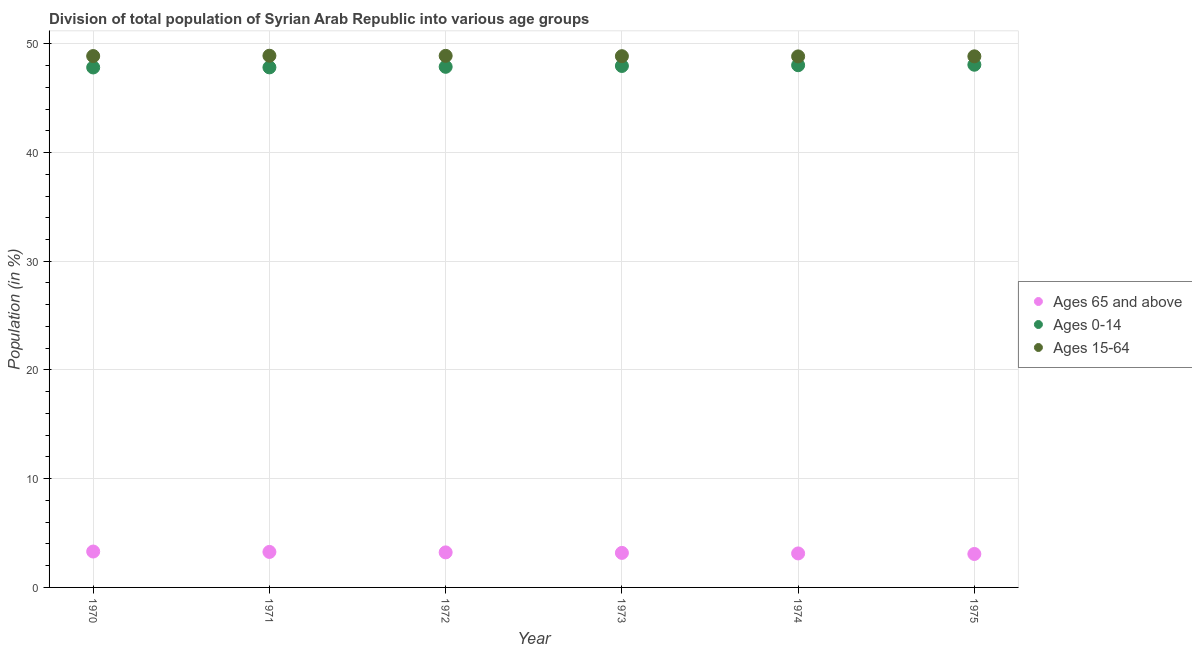How many different coloured dotlines are there?
Provide a short and direct response. 3. Is the number of dotlines equal to the number of legend labels?
Provide a short and direct response. Yes. What is the percentage of population within the age-group 0-14 in 1972?
Keep it short and to the point. 47.88. Across all years, what is the maximum percentage of population within the age-group 0-14?
Offer a terse response. 48.08. Across all years, what is the minimum percentage of population within the age-group 15-64?
Keep it short and to the point. 48.84. In which year was the percentage of population within the age-group of 65 and above minimum?
Make the answer very short. 1975. What is the total percentage of population within the age-group 0-14 in the graph?
Your response must be concise. 287.61. What is the difference between the percentage of population within the age-group of 65 and above in 1971 and that in 1974?
Your response must be concise. 0.14. What is the difference between the percentage of population within the age-group 0-14 in 1973 and the percentage of population within the age-group of 65 and above in 1971?
Your answer should be very brief. 44.7. What is the average percentage of population within the age-group 0-14 per year?
Ensure brevity in your answer.  47.93. In the year 1974, what is the difference between the percentage of population within the age-group 15-64 and percentage of population within the age-group 0-14?
Make the answer very short. 0.81. What is the ratio of the percentage of population within the age-group of 65 and above in 1970 to that in 1971?
Give a very brief answer. 1.01. Is the difference between the percentage of population within the age-group 0-14 in 1971 and 1974 greater than the difference between the percentage of population within the age-group of 65 and above in 1971 and 1974?
Ensure brevity in your answer.  No. What is the difference between the highest and the second highest percentage of population within the age-group of 65 and above?
Your answer should be very brief. 0.04. What is the difference between the highest and the lowest percentage of population within the age-group 0-14?
Provide a short and direct response. 0.25. Is the sum of the percentage of population within the age-group of 65 and above in 1970 and 1973 greater than the maximum percentage of population within the age-group 0-14 across all years?
Your answer should be compact. No. Is it the case that in every year, the sum of the percentage of population within the age-group of 65 and above and percentage of population within the age-group 0-14 is greater than the percentage of population within the age-group 15-64?
Your answer should be very brief. Yes. Is the percentage of population within the age-group 0-14 strictly less than the percentage of population within the age-group 15-64 over the years?
Make the answer very short. Yes. How many dotlines are there?
Offer a terse response. 3. What is the difference between two consecutive major ticks on the Y-axis?
Make the answer very short. 10. Where does the legend appear in the graph?
Your answer should be very brief. Center right. What is the title of the graph?
Offer a very short reply. Division of total population of Syrian Arab Republic into various age groups
. Does "Ireland" appear as one of the legend labels in the graph?
Offer a very short reply. No. What is the label or title of the X-axis?
Give a very brief answer. Year. What is the Population (in %) of Ages 65 and above in 1970?
Your response must be concise. 3.3. What is the Population (in %) of Ages 0-14 in 1970?
Your answer should be compact. 47.83. What is the Population (in %) of Ages 15-64 in 1970?
Provide a succinct answer. 48.87. What is the Population (in %) in Ages 65 and above in 1971?
Keep it short and to the point. 3.27. What is the Population (in %) of Ages 0-14 in 1971?
Your answer should be very brief. 47.83. What is the Population (in %) of Ages 15-64 in 1971?
Ensure brevity in your answer.  48.9. What is the Population (in %) in Ages 65 and above in 1972?
Your response must be concise. 3.22. What is the Population (in %) of Ages 0-14 in 1972?
Give a very brief answer. 47.88. What is the Population (in %) of Ages 15-64 in 1972?
Provide a short and direct response. 48.89. What is the Population (in %) in Ages 65 and above in 1973?
Offer a very short reply. 3.18. What is the Population (in %) in Ages 0-14 in 1973?
Your answer should be compact. 47.96. What is the Population (in %) in Ages 15-64 in 1973?
Keep it short and to the point. 48.86. What is the Population (in %) of Ages 65 and above in 1974?
Your answer should be very brief. 3.13. What is the Population (in %) in Ages 0-14 in 1974?
Ensure brevity in your answer.  48.03. What is the Population (in %) in Ages 15-64 in 1974?
Your answer should be compact. 48.84. What is the Population (in %) in Ages 65 and above in 1975?
Your response must be concise. 3.08. What is the Population (in %) of Ages 0-14 in 1975?
Make the answer very short. 48.08. What is the Population (in %) in Ages 15-64 in 1975?
Offer a terse response. 48.85. Across all years, what is the maximum Population (in %) of Ages 65 and above?
Provide a succinct answer. 3.3. Across all years, what is the maximum Population (in %) in Ages 0-14?
Your answer should be very brief. 48.08. Across all years, what is the maximum Population (in %) of Ages 15-64?
Provide a succinct answer. 48.9. Across all years, what is the minimum Population (in %) of Ages 65 and above?
Make the answer very short. 3.08. Across all years, what is the minimum Population (in %) in Ages 0-14?
Offer a terse response. 47.83. Across all years, what is the minimum Population (in %) of Ages 15-64?
Offer a terse response. 48.84. What is the total Population (in %) of Ages 65 and above in the graph?
Keep it short and to the point. 19.17. What is the total Population (in %) in Ages 0-14 in the graph?
Provide a short and direct response. 287.61. What is the total Population (in %) of Ages 15-64 in the graph?
Your answer should be compact. 293.22. What is the difference between the Population (in %) in Ages 65 and above in 1970 and that in 1971?
Provide a short and direct response. 0.04. What is the difference between the Population (in %) in Ages 0-14 in 1970 and that in 1971?
Your answer should be compact. -0.01. What is the difference between the Population (in %) of Ages 15-64 in 1970 and that in 1971?
Give a very brief answer. -0.03. What is the difference between the Population (in %) of Ages 65 and above in 1970 and that in 1972?
Your response must be concise. 0.08. What is the difference between the Population (in %) in Ages 0-14 in 1970 and that in 1972?
Ensure brevity in your answer.  -0.06. What is the difference between the Population (in %) of Ages 15-64 in 1970 and that in 1972?
Your answer should be compact. -0.02. What is the difference between the Population (in %) of Ages 65 and above in 1970 and that in 1973?
Keep it short and to the point. 0.13. What is the difference between the Population (in %) in Ages 0-14 in 1970 and that in 1973?
Provide a succinct answer. -0.14. What is the difference between the Population (in %) of Ages 15-64 in 1970 and that in 1973?
Provide a succinct answer. 0.01. What is the difference between the Population (in %) in Ages 65 and above in 1970 and that in 1974?
Offer a terse response. 0.17. What is the difference between the Population (in %) in Ages 0-14 in 1970 and that in 1974?
Give a very brief answer. -0.21. What is the difference between the Population (in %) in Ages 15-64 in 1970 and that in 1974?
Keep it short and to the point. 0.03. What is the difference between the Population (in %) of Ages 65 and above in 1970 and that in 1975?
Provide a short and direct response. 0.22. What is the difference between the Population (in %) in Ages 0-14 in 1970 and that in 1975?
Your answer should be compact. -0.25. What is the difference between the Population (in %) in Ages 15-64 in 1970 and that in 1975?
Your answer should be compact. 0.03. What is the difference between the Population (in %) of Ages 65 and above in 1971 and that in 1972?
Offer a very short reply. 0.04. What is the difference between the Population (in %) of Ages 0-14 in 1971 and that in 1972?
Ensure brevity in your answer.  -0.05. What is the difference between the Population (in %) of Ages 15-64 in 1971 and that in 1972?
Keep it short and to the point. 0.01. What is the difference between the Population (in %) in Ages 65 and above in 1971 and that in 1973?
Ensure brevity in your answer.  0.09. What is the difference between the Population (in %) of Ages 0-14 in 1971 and that in 1973?
Your answer should be compact. -0.13. What is the difference between the Population (in %) in Ages 15-64 in 1971 and that in 1973?
Keep it short and to the point. 0.04. What is the difference between the Population (in %) of Ages 65 and above in 1971 and that in 1974?
Keep it short and to the point. 0.14. What is the difference between the Population (in %) of Ages 0-14 in 1971 and that in 1974?
Keep it short and to the point. -0.2. What is the difference between the Population (in %) in Ages 15-64 in 1971 and that in 1974?
Offer a very short reply. 0.06. What is the difference between the Population (in %) of Ages 65 and above in 1971 and that in 1975?
Provide a short and direct response. 0.19. What is the difference between the Population (in %) of Ages 0-14 in 1971 and that in 1975?
Offer a very short reply. -0.24. What is the difference between the Population (in %) of Ages 15-64 in 1971 and that in 1975?
Keep it short and to the point. 0.06. What is the difference between the Population (in %) of Ages 65 and above in 1972 and that in 1973?
Your response must be concise. 0.05. What is the difference between the Population (in %) in Ages 0-14 in 1972 and that in 1973?
Ensure brevity in your answer.  -0.08. What is the difference between the Population (in %) in Ages 15-64 in 1972 and that in 1973?
Ensure brevity in your answer.  0.03. What is the difference between the Population (in %) in Ages 65 and above in 1972 and that in 1974?
Your response must be concise. 0.1. What is the difference between the Population (in %) of Ages 0-14 in 1972 and that in 1974?
Provide a succinct answer. -0.15. What is the difference between the Population (in %) of Ages 15-64 in 1972 and that in 1974?
Your answer should be very brief. 0.05. What is the difference between the Population (in %) of Ages 65 and above in 1972 and that in 1975?
Your response must be concise. 0.15. What is the difference between the Population (in %) of Ages 0-14 in 1972 and that in 1975?
Provide a succinct answer. -0.19. What is the difference between the Population (in %) of Ages 15-64 in 1972 and that in 1975?
Provide a succinct answer. 0.05. What is the difference between the Population (in %) in Ages 65 and above in 1973 and that in 1974?
Keep it short and to the point. 0.05. What is the difference between the Population (in %) of Ages 0-14 in 1973 and that in 1974?
Your response must be concise. -0.07. What is the difference between the Population (in %) in Ages 65 and above in 1973 and that in 1975?
Offer a very short reply. 0.1. What is the difference between the Population (in %) of Ages 0-14 in 1973 and that in 1975?
Keep it short and to the point. -0.11. What is the difference between the Population (in %) in Ages 15-64 in 1973 and that in 1975?
Offer a very short reply. 0.01. What is the difference between the Population (in %) of Ages 65 and above in 1974 and that in 1975?
Your response must be concise. 0.05. What is the difference between the Population (in %) of Ages 0-14 in 1974 and that in 1975?
Keep it short and to the point. -0.04. What is the difference between the Population (in %) in Ages 15-64 in 1974 and that in 1975?
Offer a terse response. -0.01. What is the difference between the Population (in %) in Ages 65 and above in 1970 and the Population (in %) in Ages 0-14 in 1971?
Keep it short and to the point. -44.53. What is the difference between the Population (in %) in Ages 65 and above in 1970 and the Population (in %) in Ages 15-64 in 1971?
Make the answer very short. -45.6. What is the difference between the Population (in %) of Ages 0-14 in 1970 and the Population (in %) of Ages 15-64 in 1971?
Your answer should be very brief. -1.08. What is the difference between the Population (in %) in Ages 65 and above in 1970 and the Population (in %) in Ages 0-14 in 1972?
Your answer should be compact. -44.58. What is the difference between the Population (in %) of Ages 65 and above in 1970 and the Population (in %) of Ages 15-64 in 1972?
Give a very brief answer. -45.59. What is the difference between the Population (in %) in Ages 0-14 in 1970 and the Population (in %) in Ages 15-64 in 1972?
Give a very brief answer. -1.07. What is the difference between the Population (in %) of Ages 65 and above in 1970 and the Population (in %) of Ages 0-14 in 1973?
Give a very brief answer. -44.66. What is the difference between the Population (in %) in Ages 65 and above in 1970 and the Population (in %) in Ages 15-64 in 1973?
Provide a succinct answer. -45.56. What is the difference between the Population (in %) of Ages 0-14 in 1970 and the Population (in %) of Ages 15-64 in 1973?
Your answer should be very brief. -1.04. What is the difference between the Population (in %) of Ages 65 and above in 1970 and the Population (in %) of Ages 0-14 in 1974?
Give a very brief answer. -44.73. What is the difference between the Population (in %) in Ages 65 and above in 1970 and the Population (in %) in Ages 15-64 in 1974?
Provide a short and direct response. -45.54. What is the difference between the Population (in %) in Ages 0-14 in 1970 and the Population (in %) in Ages 15-64 in 1974?
Provide a short and direct response. -1.02. What is the difference between the Population (in %) in Ages 65 and above in 1970 and the Population (in %) in Ages 0-14 in 1975?
Keep it short and to the point. -44.77. What is the difference between the Population (in %) in Ages 65 and above in 1970 and the Population (in %) in Ages 15-64 in 1975?
Keep it short and to the point. -45.55. What is the difference between the Population (in %) in Ages 0-14 in 1970 and the Population (in %) in Ages 15-64 in 1975?
Give a very brief answer. -1.02. What is the difference between the Population (in %) in Ages 65 and above in 1971 and the Population (in %) in Ages 0-14 in 1972?
Your answer should be very brief. -44.62. What is the difference between the Population (in %) of Ages 65 and above in 1971 and the Population (in %) of Ages 15-64 in 1972?
Ensure brevity in your answer.  -45.63. What is the difference between the Population (in %) of Ages 0-14 in 1971 and the Population (in %) of Ages 15-64 in 1972?
Provide a short and direct response. -1.06. What is the difference between the Population (in %) in Ages 65 and above in 1971 and the Population (in %) in Ages 0-14 in 1973?
Ensure brevity in your answer.  -44.7. What is the difference between the Population (in %) of Ages 65 and above in 1971 and the Population (in %) of Ages 15-64 in 1973?
Provide a short and direct response. -45.6. What is the difference between the Population (in %) of Ages 0-14 in 1971 and the Population (in %) of Ages 15-64 in 1973?
Keep it short and to the point. -1.03. What is the difference between the Population (in %) in Ages 65 and above in 1971 and the Population (in %) in Ages 0-14 in 1974?
Give a very brief answer. -44.77. What is the difference between the Population (in %) of Ages 65 and above in 1971 and the Population (in %) of Ages 15-64 in 1974?
Keep it short and to the point. -45.58. What is the difference between the Population (in %) of Ages 0-14 in 1971 and the Population (in %) of Ages 15-64 in 1974?
Make the answer very short. -1.01. What is the difference between the Population (in %) in Ages 65 and above in 1971 and the Population (in %) in Ages 0-14 in 1975?
Give a very brief answer. -44.81. What is the difference between the Population (in %) of Ages 65 and above in 1971 and the Population (in %) of Ages 15-64 in 1975?
Your answer should be very brief. -45.58. What is the difference between the Population (in %) in Ages 0-14 in 1971 and the Population (in %) in Ages 15-64 in 1975?
Your response must be concise. -1.02. What is the difference between the Population (in %) in Ages 65 and above in 1972 and the Population (in %) in Ages 0-14 in 1973?
Your response must be concise. -44.74. What is the difference between the Population (in %) in Ages 65 and above in 1972 and the Population (in %) in Ages 15-64 in 1973?
Make the answer very short. -45.64. What is the difference between the Population (in %) of Ages 0-14 in 1972 and the Population (in %) of Ages 15-64 in 1973?
Your answer should be compact. -0.98. What is the difference between the Population (in %) in Ages 65 and above in 1972 and the Population (in %) in Ages 0-14 in 1974?
Provide a succinct answer. -44.81. What is the difference between the Population (in %) in Ages 65 and above in 1972 and the Population (in %) in Ages 15-64 in 1974?
Provide a succinct answer. -45.62. What is the difference between the Population (in %) of Ages 0-14 in 1972 and the Population (in %) of Ages 15-64 in 1974?
Offer a very short reply. -0.96. What is the difference between the Population (in %) in Ages 65 and above in 1972 and the Population (in %) in Ages 0-14 in 1975?
Ensure brevity in your answer.  -44.85. What is the difference between the Population (in %) in Ages 65 and above in 1972 and the Population (in %) in Ages 15-64 in 1975?
Keep it short and to the point. -45.62. What is the difference between the Population (in %) in Ages 0-14 in 1972 and the Population (in %) in Ages 15-64 in 1975?
Offer a very short reply. -0.96. What is the difference between the Population (in %) of Ages 65 and above in 1973 and the Population (in %) of Ages 0-14 in 1974?
Provide a short and direct response. -44.85. What is the difference between the Population (in %) in Ages 65 and above in 1973 and the Population (in %) in Ages 15-64 in 1974?
Offer a very short reply. -45.67. What is the difference between the Population (in %) of Ages 0-14 in 1973 and the Population (in %) of Ages 15-64 in 1974?
Make the answer very short. -0.88. What is the difference between the Population (in %) in Ages 65 and above in 1973 and the Population (in %) in Ages 0-14 in 1975?
Provide a succinct answer. -44.9. What is the difference between the Population (in %) in Ages 65 and above in 1973 and the Population (in %) in Ages 15-64 in 1975?
Make the answer very short. -45.67. What is the difference between the Population (in %) of Ages 0-14 in 1973 and the Population (in %) of Ages 15-64 in 1975?
Ensure brevity in your answer.  -0.89. What is the difference between the Population (in %) of Ages 65 and above in 1974 and the Population (in %) of Ages 0-14 in 1975?
Keep it short and to the point. -44.95. What is the difference between the Population (in %) in Ages 65 and above in 1974 and the Population (in %) in Ages 15-64 in 1975?
Offer a terse response. -45.72. What is the difference between the Population (in %) in Ages 0-14 in 1974 and the Population (in %) in Ages 15-64 in 1975?
Ensure brevity in your answer.  -0.82. What is the average Population (in %) of Ages 65 and above per year?
Make the answer very short. 3.2. What is the average Population (in %) in Ages 0-14 per year?
Your answer should be compact. 47.93. What is the average Population (in %) in Ages 15-64 per year?
Make the answer very short. 48.87. In the year 1970, what is the difference between the Population (in %) of Ages 65 and above and Population (in %) of Ages 0-14?
Give a very brief answer. -44.52. In the year 1970, what is the difference between the Population (in %) in Ages 65 and above and Population (in %) in Ages 15-64?
Provide a succinct answer. -45.57. In the year 1970, what is the difference between the Population (in %) of Ages 0-14 and Population (in %) of Ages 15-64?
Your response must be concise. -1.05. In the year 1971, what is the difference between the Population (in %) of Ages 65 and above and Population (in %) of Ages 0-14?
Make the answer very short. -44.57. In the year 1971, what is the difference between the Population (in %) in Ages 65 and above and Population (in %) in Ages 15-64?
Give a very brief answer. -45.64. In the year 1971, what is the difference between the Population (in %) in Ages 0-14 and Population (in %) in Ages 15-64?
Offer a terse response. -1.07. In the year 1972, what is the difference between the Population (in %) in Ages 65 and above and Population (in %) in Ages 0-14?
Give a very brief answer. -44.66. In the year 1972, what is the difference between the Population (in %) in Ages 65 and above and Population (in %) in Ages 15-64?
Your response must be concise. -45.67. In the year 1972, what is the difference between the Population (in %) of Ages 0-14 and Population (in %) of Ages 15-64?
Your answer should be compact. -1.01. In the year 1973, what is the difference between the Population (in %) of Ages 65 and above and Population (in %) of Ages 0-14?
Provide a short and direct response. -44.79. In the year 1973, what is the difference between the Population (in %) in Ages 65 and above and Population (in %) in Ages 15-64?
Provide a succinct answer. -45.69. In the year 1973, what is the difference between the Population (in %) of Ages 0-14 and Population (in %) of Ages 15-64?
Your answer should be very brief. -0.9. In the year 1974, what is the difference between the Population (in %) of Ages 65 and above and Population (in %) of Ages 0-14?
Provide a succinct answer. -44.9. In the year 1974, what is the difference between the Population (in %) of Ages 65 and above and Population (in %) of Ages 15-64?
Give a very brief answer. -45.71. In the year 1974, what is the difference between the Population (in %) in Ages 0-14 and Population (in %) in Ages 15-64?
Keep it short and to the point. -0.81. In the year 1975, what is the difference between the Population (in %) of Ages 65 and above and Population (in %) of Ages 0-14?
Your answer should be compact. -45. In the year 1975, what is the difference between the Population (in %) of Ages 65 and above and Population (in %) of Ages 15-64?
Ensure brevity in your answer.  -45.77. In the year 1975, what is the difference between the Population (in %) in Ages 0-14 and Population (in %) in Ages 15-64?
Ensure brevity in your answer.  -0.77. What is the ratio of the Population (in %) of Ages 65 and above in 1970 to that in 1971?
Your answer should be very brief. 1.01. What is the ratio of the Population (in %) in Ages 0-14 in 1970 to that in 1971?
Give a very brief answer. 1. What is the ratio of the Population (in %) of Ages 65 and above in 1970 to that in 1972?
Provide a short and direct response. 1.02. What is the ratio of the Population (in %) in Ages 0-14 in 1970 to that in 1972?
Ensure brevity in your answer.  1. What is the ratio of the Population (in %) of Ages 65 and above in 1970 to that in 1973?
Your answer should be compact. 1.04. What is the ratio of the Population (in %) of Ages 65 and above in 1970 to that in 1974?
Make the answer very short. 1.06. What is the ratio of the Population (in %) in Ages 15-64 in 1970 to that in 1974?
Give a very brief answer. 1. What is the ratio of the Population (in %) of Ages 65 and above in 1970 to that in 1975?
Keep it short and to the point. 1.07. What is the ratio of the Population (in %) of Ages 0-14 in 1970 to that in 1975?
Keep it short and to the point. 0.99. What is the ratio of the Population (in %) in Ages 65 and above in 1971 to that in 1972?
Provide a short and direct response. 1.01. What is the ratio of the Population (in %) of Ages 15-64 in 1971 to that in 1972?
Make the answer very short. 1. What is the ratio of the Population (in %) in Ages 65 and above in 1971 to that in 1973?
Provide a succinct answer. 1.03. What is the ratio of the Population (in %) of Ages 0-14 in 1971 to that in 1973?
Your answer should be very brief. 1. What is the ratio of the Population (in %) of Ages 65 and above in 1971 to that in 1974?
Keep it short and to the point. 1.04. What is the ratio of the Population (in %) of Ages 0-14 in 1971 to that in 1974?
Give a very brief answer. 1. What is the ratio of the Population (in %) in Ages 15-64 in 1971 to that in 1974?
Ensure brevity in your answer.  1. What is the ratio of the Population (in %) in Ages 65 and above in 1971 to that in 1975?
Offer a very short reply. 1.06. What is the ratio of the Population (in %) in Ages 0-14 in 1971 to that in 1975?
Provide a short and direct response. 0.99. What is the ratio of the Population (in %) of Ages 15-64 in 1971 to that in 1975?
Offer a very short reply. 1. What is the ratio of the Population (in %) of Ages 65 and above in 1972 to that in 1973?
Offer a terse response. 1.01. What is the ratio of the Population (in %) in Ages 65 and above in 1972 to that in 1974?
Keep it short and to the point. 1.03. What is the ratio of the Population (in %) in Ages 65 and above in 1972 to that in 1975?
Provide a succinct answer. 1.05. What is the ratio of the Population (in %) of Ages 0-14 in 1972 to that in 1975?
Keep it short and to the point. 1. What is the ratio of the Population (in %) of Ages 65 and above in 1973 to that in 1974?
Make the answer very short. 1.02. What is the ratio of the Population (in %) of Ages 0-14 in 1973 to that in 1974?
Your response must be concise. 1. What is the ratio of the Population (in %) in Ages 15-64 in 1973 to that in 1974?
Your answer should be compact. 1. What is the ratio of the Population (in %) of Ages 65 and above in 1973 to that in 1975?
Keep it short and to the point. 1.03. What is the ratio of the Population (in %) in Ages 15-64 in 1973 to that in 1975?
Keep it short and to the point. 1. What is the ratio of the Population (in %) of Ages 65 and above in 1974 to that in 1975?
Ensure brevity in your answer.  1.02. What is the difference between the highest and the second highest Population (in %) in Ages 65 and above?
Make the answer very short. 0.04. What is the difference between the highest and the second highest Population (in %) of Ages 0-14?
Give a very brief answer. 0.04. What is the difference between the highest and the second highest Population (in %) of Ages 15-64?
Offer a very short reply. 0.01. What is the difference between the highest and the lowest Population (in %) of Ages 65 and above?
Offer a very short reply. 0.22. What is the difference between the highest and the lowest Population (in %) in Ages 0-14?
Make the answer very short. 0.25. What is the difference between the highest and the lowest Population (in %) of Ages 15-64?
Make the answer very short. 0.06. 